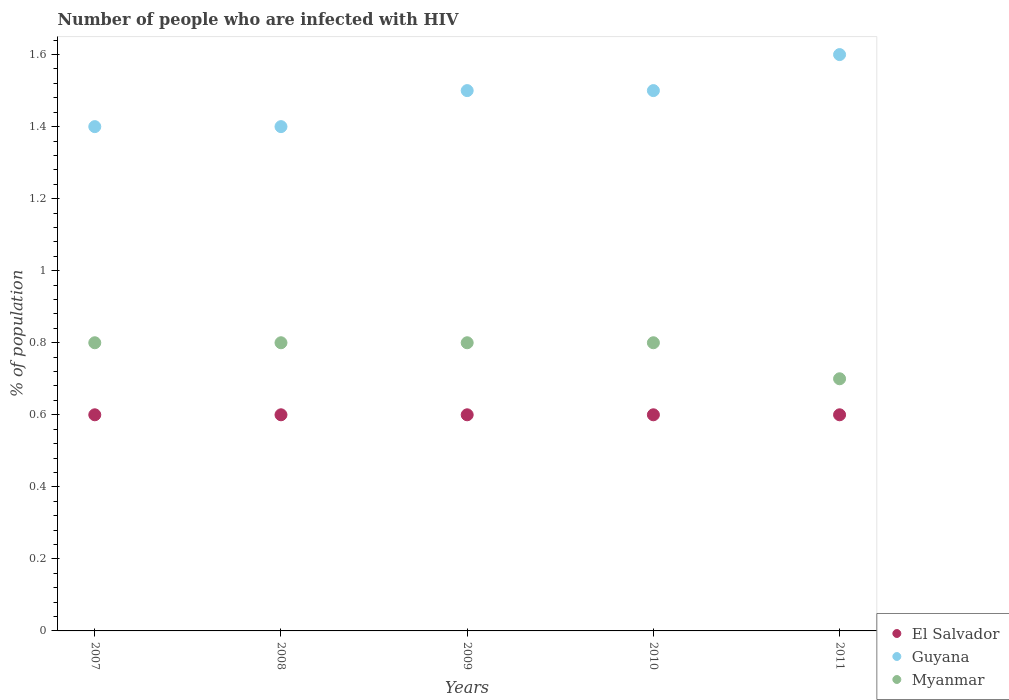Is the number of dotlines equal to the number of legend labels?
Make the answer very short. Yes. Across all years, what is the maximum percentage of HIV infected population in in Myanmar?
Provide a short and direct response. 0.8. Across all years, what is the minimum percentage of HIV infected population in in El Salvador?
Your answer should be very brief. 0.6. In which year was the percentage of HIV infected population in in Myanmar maximum?
Offer a terse response. 2007. In which year was the percentage of HIV infected population in in Guyana minimum?
Your answer should be very brief. 2007. What is the difference between the percentage of HIV infected population in in Myanmar in 2009 and the percentage of HIV infected population in in El Salvador in 2010?
Make the answer very short. 0.2. What is the average percentage of HIV infected population in in Guyana per year?
Your answer should be compact. 1.48. In the year 2008, what is the difference between the percentage of HIV infected population in in Guyana and percentage of HIV infected population in in El Salvador?
Your response must be concise. 0.8. In how many years, is the percentage of HIV infected population in in Guyana greater than 0.88 %?
Ensure brevity in your answer.  5. What is the ratio of the percentage of HIV infected population in in Guyana in 2008 to that in 2011?
Offer a terse response. 0.87. Is the percentage of HIV infected population in in Myanmar in 2008 less than that in 2009?
Keep it short and to the point. No. What is the difference between the highest and the second highest percentage of HIV infected population in in Myanmar?
Offer a terse response. 0. What is the difference between the highest and the lowest percentage of HIV infected population in in Guyana?
Ensure brevity in your answer.  0.2. Is it the case that in every year, the sum of the percentage of HIV infected population in in Myanmar and percentage of HIV infected population in in El Salvador  is greater than the percentage of HIV infected population in in Guyana?
Provide a succinct answer. No. Does the percentage of HIV infected population in in Guyana monotonically increase over the years?
Offer a very short reply. No. Are the values on the major ticks of Y-axis written in scientific E-notation?
Give a very brief answer. No. Does the graph contain grids?
Provide a succinct answer. No. How many legend labels are there?
Offer a very short reply. 3. What is the title of the graph?
Give a very brief answer. Number of people who are infected with HIV. What is the label or title of the Y-axis?
Keep it short and to the point. % of population. What is the % of population of Myanmar in 2007?
Ensure brevity in your answer.  0.8. What is the % of population in El Salvador in 2008?
Offer a terse response. 0.6. What is the % of population in Myanmar in 2008?
Provide a succinct answer. 0.8. What is the % of population in El Salvador in 2010?
Give a very brief answer. 0.6. What is the % of population in El Salvador in 2011?
Keep it short and to the point. 0.6. Across all years, what is the maximum % of population of El Salvador?
Ensure brevity in your answer.  0.6. Across all years, what is the maximum % of population of Myanmar?
Give a very brief answer. 0.8. Across all years, what is the minimum % of population in El Salvador?
Your answer should be very brief. 0.6. Across all years, what is the minimum % of population in Myanmar?
Offer a very short reply. 0.7. What is the total % of population in Myanmar in the graph?
Give a very brief answer. 3.9. What is the difference between the % of population of Guyana in 2007 and that in 2008?
Give a very brief answer. 0. What is the difference between the % of population in El Salvador in 2007 and that in 2009?
Your answer should be very brief. 0. What is the difference between the % of population in Guyana in 2007 and that in 2010?
Ensure brevity in your answer.  -0.1. What is the difference between the % of population in Myanmar in 2007 and that in 2010?
Make the answer very short. 0. What is the difference between the % of population of Guyana in 2007 and that in 2011?
Provide a succinct answer. -0.2. What is the difference between the % of population in Myanmar in 2007 and that in 2011?
Your answer should be compact. 0.1. What is the difference between the % of population in El Salvador in 2008 and that in 2009?
Keep it short and to the point. 0. What is the difference between the % of population of Guyana in 2008 and that in 2009?
Your response must be concise. -0.1. What is the difference between the % of population of Myanmar in 2008 and that in 2009?
Give a very brief answer. 0. What is the difference between the % of population in Myanmar in 2008 and that in 2011?
Make the answer very short. 0.1. What is the difference between the % of population in Myanmar in 2009 and that in 2010?
Provide a short and direct response. 0. What is the difference between the % of population in El Salvador in 2009 and that in 2011?
Ensure brevity in your answer.  0. What is the difference between the % of population in Guyana in 2009 and that in 2011?
Offer a very short reply. -0.1. What is the difference between the % of population of El Salvador in 2010 and that in 2011?
Ensure brevity in your answer.  0. What is the difference between the % of population in Myanmar in 2010 and that in 2011?
Keep it short and to the point. 0.1. What is the difference between the % of population in El Salvador in 2007 and the % of population in Guyana in 2009?
Your response must be concise. -0.9. What is the difference between the % of population of El Salvador in 2007 and the % of population of Guyana in 2010?
Your answer should be very brief. -0.9. What is the difference between the % of population of El Salvador in 2007 and the % of population of Guyana in 2011?
Offer a terse response. -1. What is the difference between the % of population of El Salvador in 2007 and the % of population of Myanmar in 2011?
Keep it short and to the point. -0.1. What is the difference between the % of population of El Salvador in 2008 and the % of population of Guyana in 2009?
Ensure brevity in your answer.  -0.9. What is the difference between the % of population in El Salvador in 2008 and the % of population in Guyana in 2010?
Make the answer very short. -0.9. What is the difference between the % of population of El Salvador in 2008 and the % of population of Myanmar in 2011?
Ensure brevity in your answer.  -0.1. What is the difference between the % of population in El Salvador in 2009 and the % of population in Guyana in 2010?
Your response must be concise. -0.9. What is the difference between the % of population of Guyana in 2009 and the % of population of Myanmar in 2010?
Your response must be concise. 0.7. What is the difference between the % of population in El Salvador in 2009 and the % of population in Guyana in 2011?
Ensure brevity in your answer.  -1. What is the difference between the % of population in El Salvador in 2009 and the % of population in Myanmar in 2011?
Your answer should be very brief. -0.1. What is the difference between the % of population in El Salvador in 2010 and the % of population in Myanmar in 2011?
Your answer should be compact. -0.1. What is the difference between the % of population of Guyana in 2010 and the % of population of Myanmar in 2011?
Provide a succinct answer. 0.8. What is the average % of population of Guyana per year?
Offer a very short reply. 1.48. What is the average % of population in Myanmar per year?
Give a very brief answer. 0.78. In the year 2007, what is the difference between the % of population in El Salvador and % of population in Guyana?
Make the answer very short. -0.8. In the year 2007, what is the difference between the % of population of Guyana and % of population of Myanmar?
Your answer should be very brief. 0.6. In the year 2008, what is the difference between the % of population in El Salvador and % of population in Guyana?
Give a very brief answer. -0.8. In the year 2008, what is the difference between the % of population of Guyana and % of population of Myanmar?
Ensure brevity in your answer.  0.6. In the year 2009, what is the difference between the % of population of El Salvador and % of population of Guyana?
Your answer should be compact. -0.9. In the year 2009, what is the difference between the % of population in El Salvador and % of population in Myanmar?
Give a very brief answer. -0.2. In the year 2010, what is the difference between the % of population of El Salvador and % of population of Guyana?
Your answer should be very brief. -0.9. What is the ratio of the % of population of El Salvador in 2007 to that in 2008?
Keep it short and to the point. 1. What is the ratio of the % of population of El Salvador in 2007 to that in 2009?
Make the answer very short. 1. What is the ratio of the % of population of El Salvador in 2007 to that in 2010?
Offer a terse response. 1. What is the ratio of the % of population in Guyana in 2007 to that in 2010?
Offer a very short reply. 0.93. What is the ratio of the % of population of Myanmar in 2007 to that in 2010?
Offer a very short reply. 1. What is the ratio of the % of population of El Salvador in 2008 to that in 2009?
Your response must be concise. 1. What is the ratio of the % of population in El Salvador in 2008 to that in 2010?
Provide a succinct answer. 1. What is the ratio of the % of population of El Salvador in 2009 to that in 2010?
Your answer should be compact. 1. What is the ratio of the % of population of Myanmar in 2009 to that in 2010?
Keep it short and to the point. 1. What is the ratio of the % of population of El Salvador in 2009 to that in 2011?
Your answer should be very brief. 1. What is the ratio of the % of population of El Salvador in 2010 to that in 2011?
Your answer should be compact. 1. What is the ratio of the % of population in Myanmar in 2010 to that in 2011?
Provide a succinct answer. 1.14. What is the difference between the highest and the second highest % of population of Guyana?
Your answer should be compact. 0.1. What is the difference between the highest and the lowest % of population in Guyana?
Ensure brevity in your answer.  0.2. What is the difference between the highest and the lowest % of population in Myanmar?
Provide a short and direct response. 0.1. 